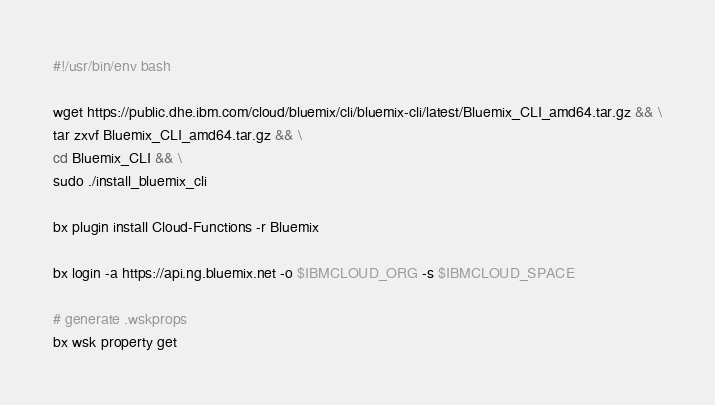Convert code to text. <code><loc_0><loc_0><loc_500><loc_500><_Bash_>#!/usr/bin/env bash

wget https://public.dhe.ibm.com/cloud/bluemix/cli/bluemix-cli/latest/Bluemix_CLI_amd64.tar.gz && \
tar zxvf Bluemix_CLI_amd64.tar.gz && \
cd Bluemix_CLI && \
sudo ./install_bluemix_cli

bx plugin install Cloud-Functions -r Bluemix

bx login -a https://api.ng.bluemix.net -o $IBMCLOUD_ORG -s $IBMCLOUD_SPACE

# generate .wskprops
bx wsk property get
</code> 